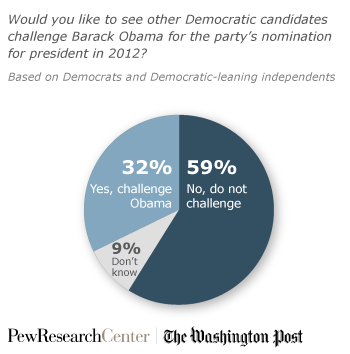List a handful of essential elements in this visual. The answer is that the sum of 'Yes,' 'Challenge,' and 'Don't know' is more than 'No,' and therefore, one should not challenge with this information alone. 